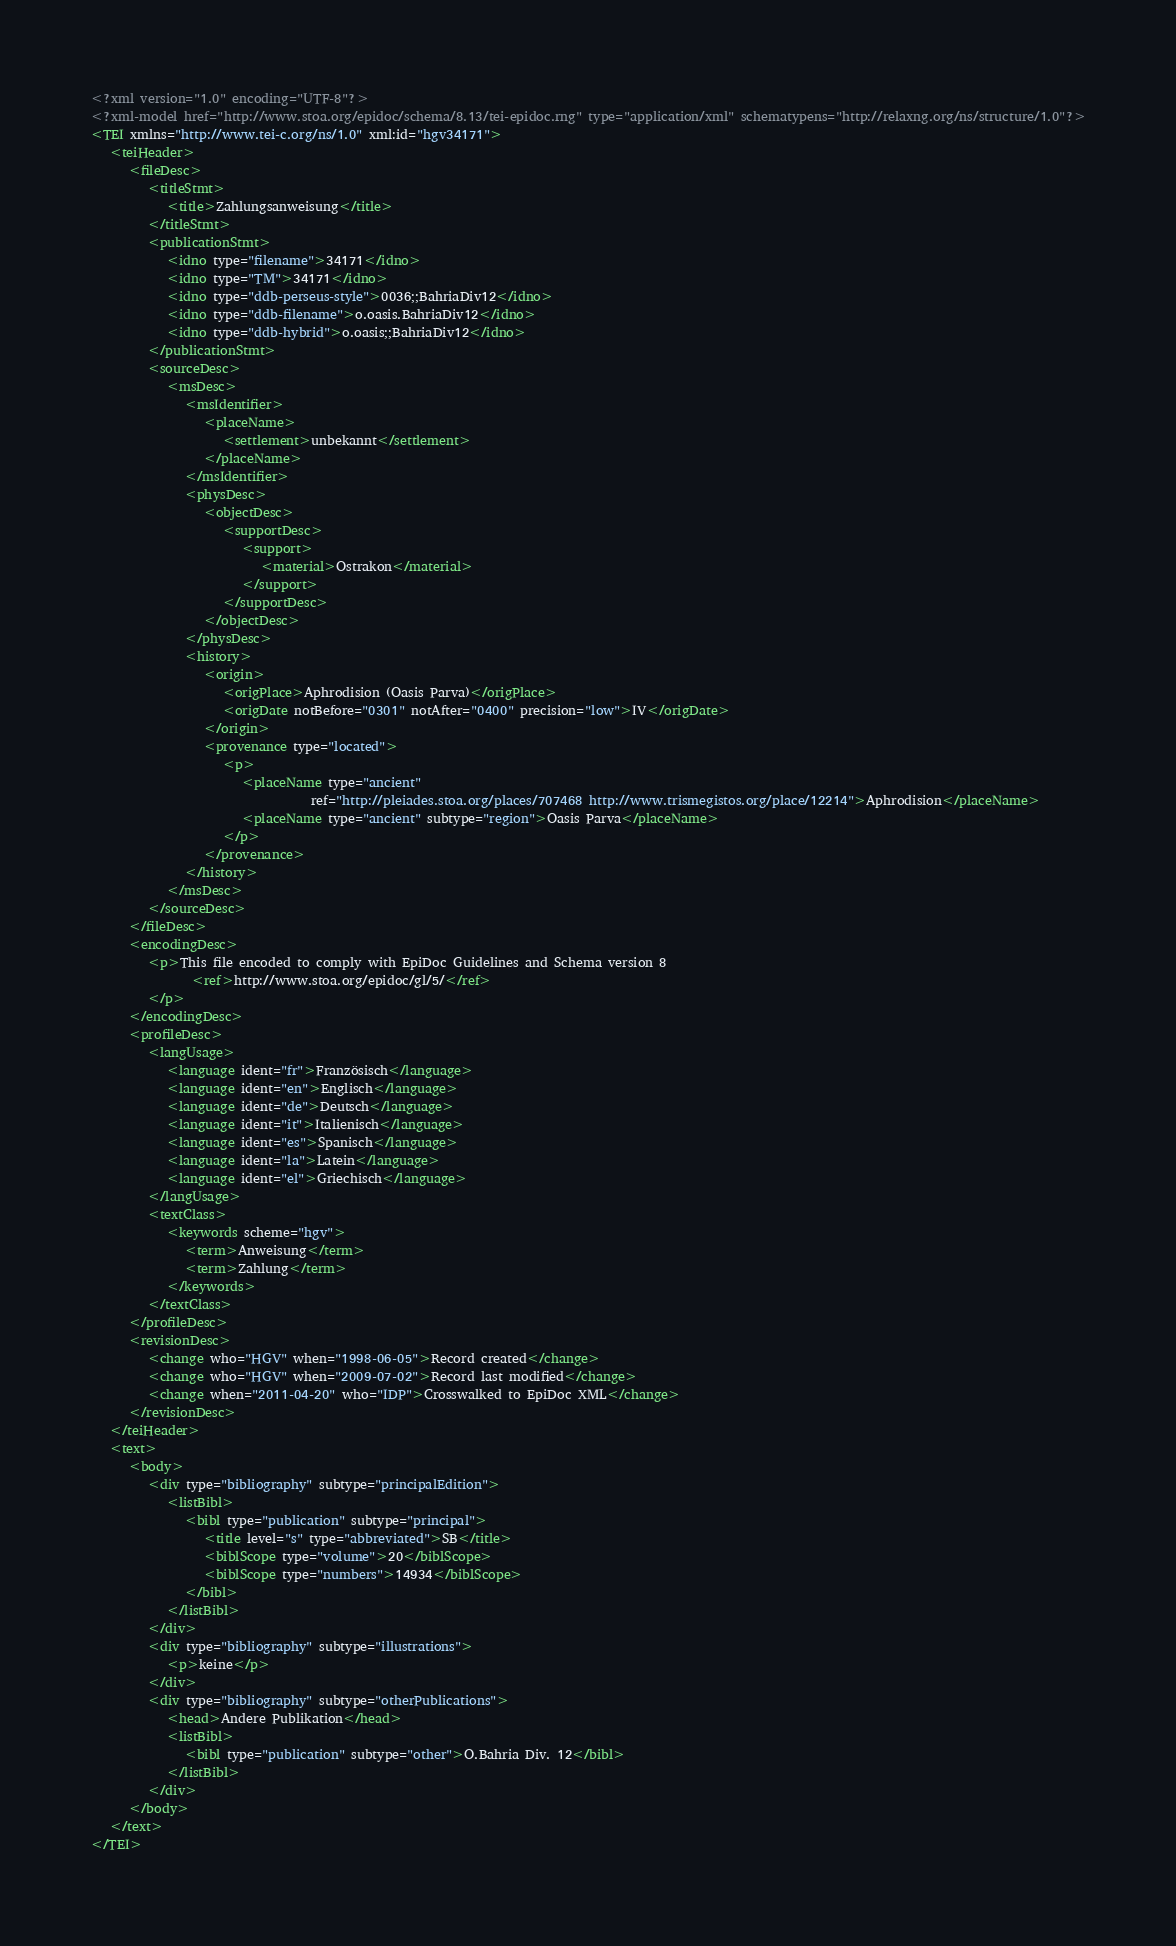Convert code to text. <code><loc_0><loc_0><loc_500><loc_500><_XML_><?xml version="1.0" encoding="UTF-8"?>
<?xml-model href="http://www.stoa.org/epidoc/schema/8.13/tei-epidoc.rng" type="application/xml" schematypens="http://relaxng.org/ns/structure/1.0"?>
<TEI xmlns="http://www.tei-c.org/ns/1.0" xml:id="hgv34171">
   <teiHeader>
      <fileDesc>
         <titleStmt>
            <title>Zahlungsanweisung</title>
         </titleStmt>
         <publicationStmt>
            <idno type="filename">34171</idno>
            <idno type="TM">34171</idno>
            <idno type="ddb-perseus-style">0036;;BahriaDiv12</idno>
            <idno type="ddb-filename">o.oasis.BahriaDiv12</idno>
            <idno type="ddb-hybrid">o.oasis;;BahriaDiv12</idno>
         </publicationStmt>
         <sourceDesc>
            <msDesc>
               <msIdentifier>
                  <placeName>
                     <settlement>unbekannt</settlement>
                  </placeName>
               </msIdentifier>
               <physDesc>
                  <objectDesc>
                     <supportDesc>
                        <support>
                           <material>Ostrakon</material>
                        </support>
                     </supportDesc>
                  </objectDesc>
               </physDesc>
               <history>
                  <origin>
                     <origPlace>Aphrodision (Oasis Parva)</origPlace>
                     <origDate notBefore="0301" notAfter="0400" precision="low">IV</origDate>
                  </origin>
                  <provenance type="located">
                     <p>
                        <placeName type="ancient"
                                   ref="http://pleiades.stoa.org/places/707468 http://www.trismegistos.org/place/12214">Aphrodision</placeName>
                        <placeName type="ancient" subtype="region">Oasis Parva</placeName>
                     </p>
                  </provenance>
               </history>
            </msDesc>
         </sourceDesc>
      </fileDesc>
      <encodingDesc>
         <p>This file encoded to comply with EpiDoc Guidelines and Schema version 8
                <ref>http://www.stoa.org/epidoc/gl/5/</ref>
         </p>
      </encodingDesc>
      <profileDesc>
         <langUsage>
            <language ident="fr">Französisch</language>
            <language ident="en">Englisch</language>
            <language ident="de">Deutsch</language>
            <language ident="it">Italienisch</language>
            <language ident="es">Spanisch</language>
            <language ident="la">Latein</language>
            <language ident="el">Griechisch</language>
         </langUsage>
         <textClass>
            <keywords scheme="hgv">
               <term>Anweisung</term>
               <term>Zahlung</term>
            </keywords>
         </textClass>
      </profileDesc>
      <revisionDesc>
         <change who="HGV" when="1998-06-05">Record created</change>
         <change who="HGV" when="2009-07-02">Record last modified</change>
         <change when="2011-04-20" who="IDP">Crosswalked to EpiDoc XML</change>
      </revisionDesc>
   </teiHeader>
   <text>
      <body>
         <div type="bibliography" subtype="principalEdition">
            <listBibl>
               <bibl type="publication" subtype="principal">
                  <title level="s" type="abbreviated">SB</title>
                  <biblScope type="volume">20</biblScope>
                  <biblScope type="numbers">14934</biblScope>
               </bibl>
            </listBibl>
         </div>
         <div type="bibliography" subtype="illustrations">
            <p>keine</p>
         </div>
         <div type="bibliography" subtype="otherPublications">
            <head>Andere Publikation</head>
            <listBibl>
               <bibl type="publication" subtype="other">O.Bahria Div. 12</bibl>
            </listBibl>
         </div>
      </body>
   </text>
</TEI>
</code> 